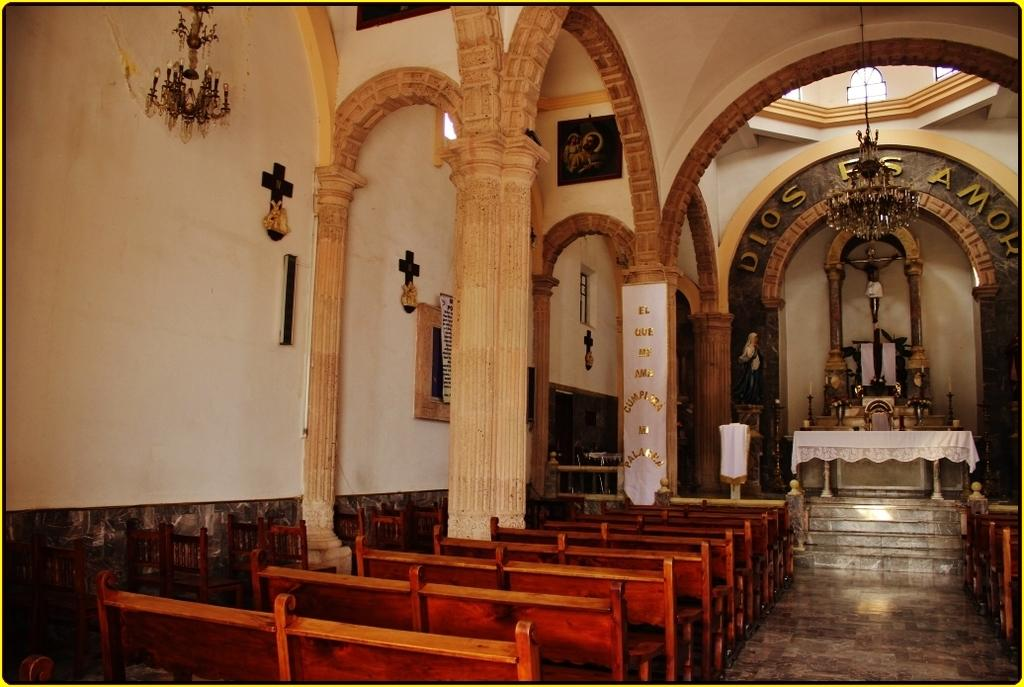What type of seating is located on the left side of the image? There are benches on the left side of the image. What can be seen at the top of the image? There are lights visible at the top of the image. What is written on a wall in the background of the image? There is text written on a wall in the background of the image. How many brothers are standing next to the benches in the image? There is no mention of brothers in the image, and therefore no such information can be provided. What type of veil is draped over the lights at the top of the image? There is no veil present in the image; only lights are visible at the top. 